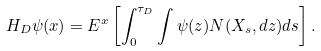<formula> <loc_0><loc_0><loc_500><loc_500>H _ { D } \psi ( x ) = E ^ { x } \left [ \int _ { 0 } ^ { \tau _ { D } } \int \psi ( z ) N ( X _ { s } , d z ) d s \right ] .</formula> 